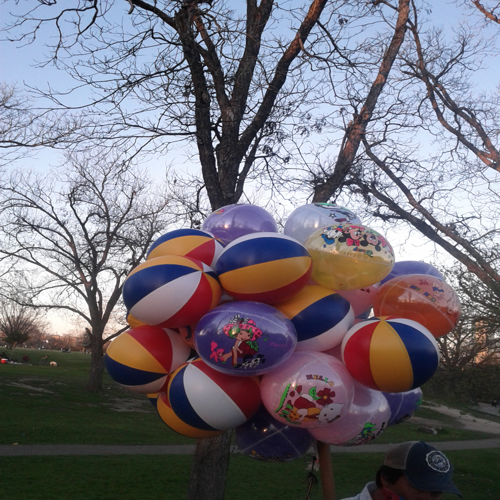Can you tell me more about the setting where this picture was taken? The setting appears to be an open outdoor area, likely a public park due to the presence of well-maintained grassy areas, trees in the background, and the relaxed ambiance. Such settings often serve as popular spots for family gatherings, community events, or simply enjoying a pleasant day outside. Are there any notable features in the environment that provide clues about the location? There aren't any immediately identifiable landmarks that would conclusively pinpoint the location. However, it seems to be a temperate zone due to the type of trees and the quality of light, suggesting it could be late afternoon to early evening, which is a popular time for people to visit parks. 